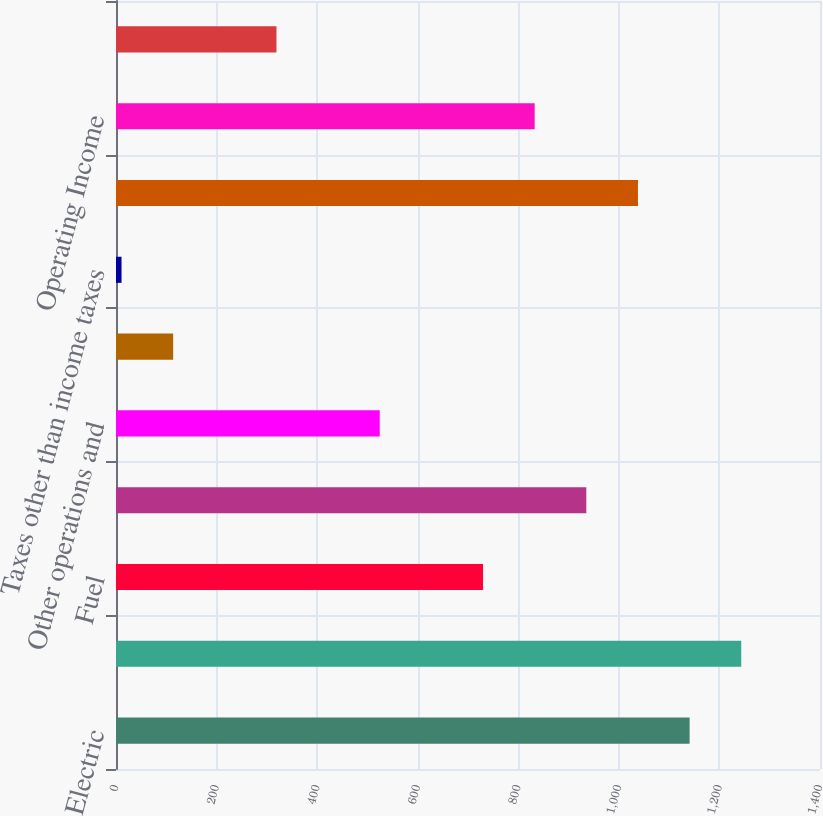<chart> <loc_0><loc_0><loc_500><loc_500><bar_chart><fcel>Electric<fcel>Total operating revenues<fcel>Fuel<fcel>Purchased power<fcel>Other operations and<fcel>Depreciation and amortization<fcel>Taxes other than income taxes<fcel>Total operating expenses<fcel>Operating Income<fcel>Interest Charges<nl><fcel>1140.7<fcel>1243.4<fcel>729.9<fcel>935.3<fcel>524.5<fcel>113.7<fcel>11<fcel>1038<fcel>832.6<fcel>319.1<nl></chart> 